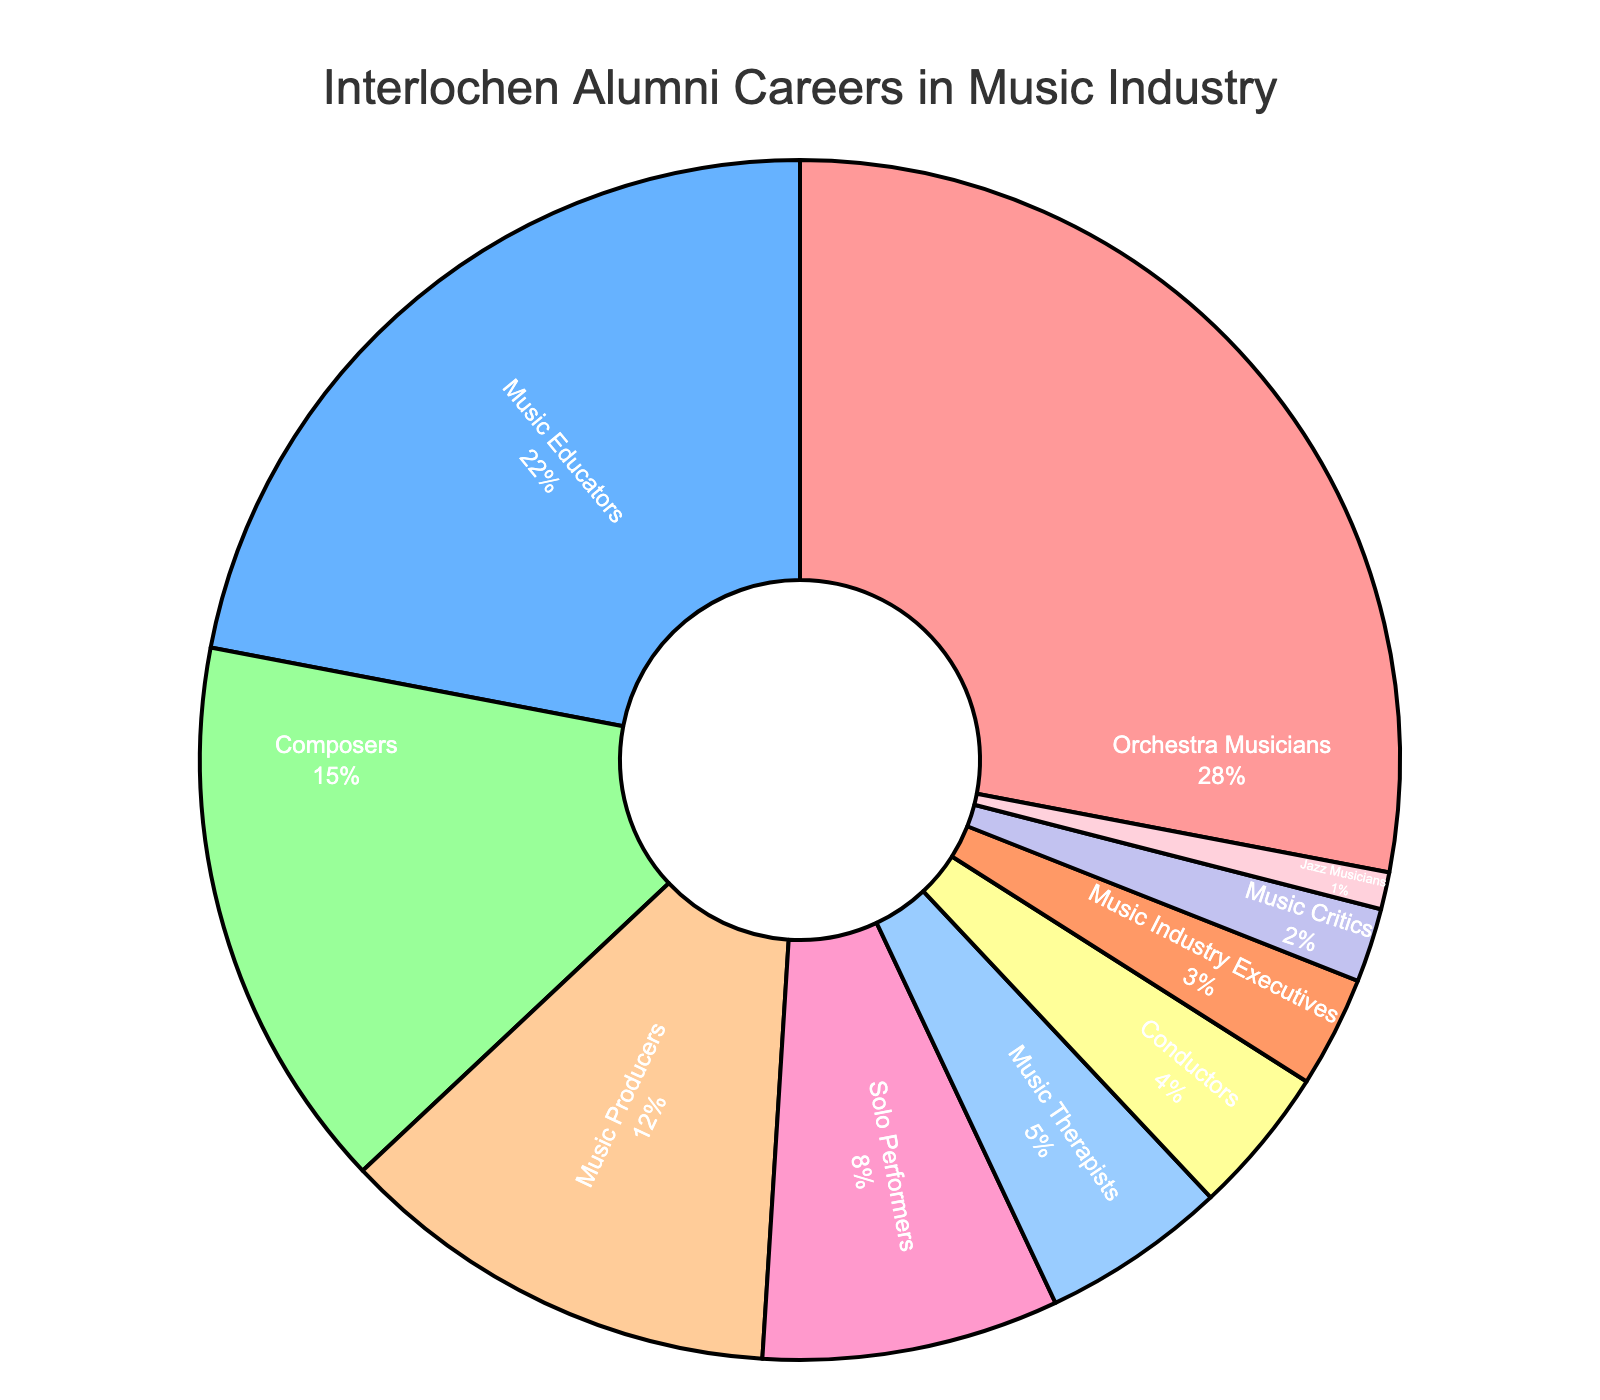How many more Orchestra Musicians are there compared to Jazz Musicians? The percentage for Orchestra Musicians is 28%, and for Jazz Musicians, it is 1%. Subtracting the two, we get 28% - 1% = 27%.
Answer: 27% Which career has the smallest proportion of Interlochen alumni? Looking at the figures, Jazz Musicians have the smallest proportion at 1%.
Answer: Jazz Musicians What is the total percentage of Interlochen alumni working as Music Educators, Composers, and Solo Performers? Add the percentages for Music Educators (22%), Composers (15%), and Solo Performers (8%): 22% + 15% + 8% = 45%.
Answer: 45% Are there more Music Producers or Music Therapists among Interlochen alumni? The proportion of Music Producers is 12%, while Music Therapists is 5%. Since 12% is greater than 5%, there are more Music Producers.
Answer: Music Producers By how much do Orchestra Musicians outnumber Music Industry Executives? The percentage for Orchestra Musicians is 28%, and for Music Industry Executives, it is 3%. Subtracting the two, we get 28% - 3% = 25%.
Answer: 25% What's the difference between the percentage of Music Educators and Conductors? Music Educators make up 22%, and Conductors make up 4%. The difference is 22% - 4% = 18%.
Answer: 18% What career has the second-largest proportion of Interlochen alumni? The second-largest proportion of Interlochen alumni is in the Music Educators career at 22%.
Answer: Music Educators Which career sections are represented with red and blue colors? Referring to the visual attributes, Orchestra Musicians are shown in red and Music Educators are in blue.
Answer: Orchestra Musicians (red) and Music Educators (blue) Sum all the percentages of careers that make up less than 10% of Interlochen alumni each. Summing the percentages of Solo Performers (8%), Music Therapists (5%), Conductors (4%), Music Industry Executives (3%), Music Critics (2%), and Jazz Musicians (1%): 8% + 5% + 4% + 3% + 2% + 1% = 23%.
Answer: 23% Which section has a pinkish color and what career does it represent? The pinkish color corresponds to the Solo Performers career, which makes up 8%.
Answer: Solo Performers 